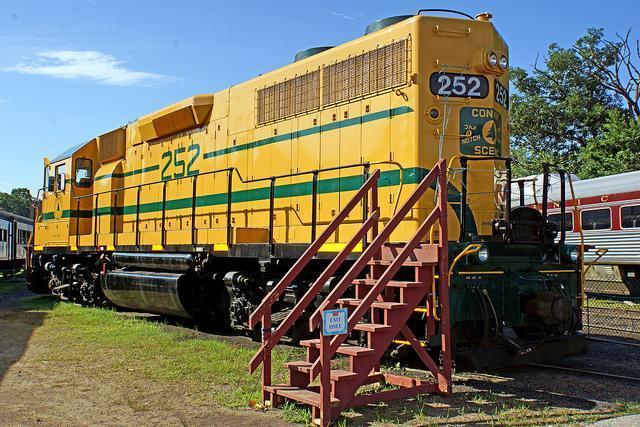How many stairs are near the train?
Give a very brief answer. 8. How many trains are there?
Give a very brief answer. 2. 